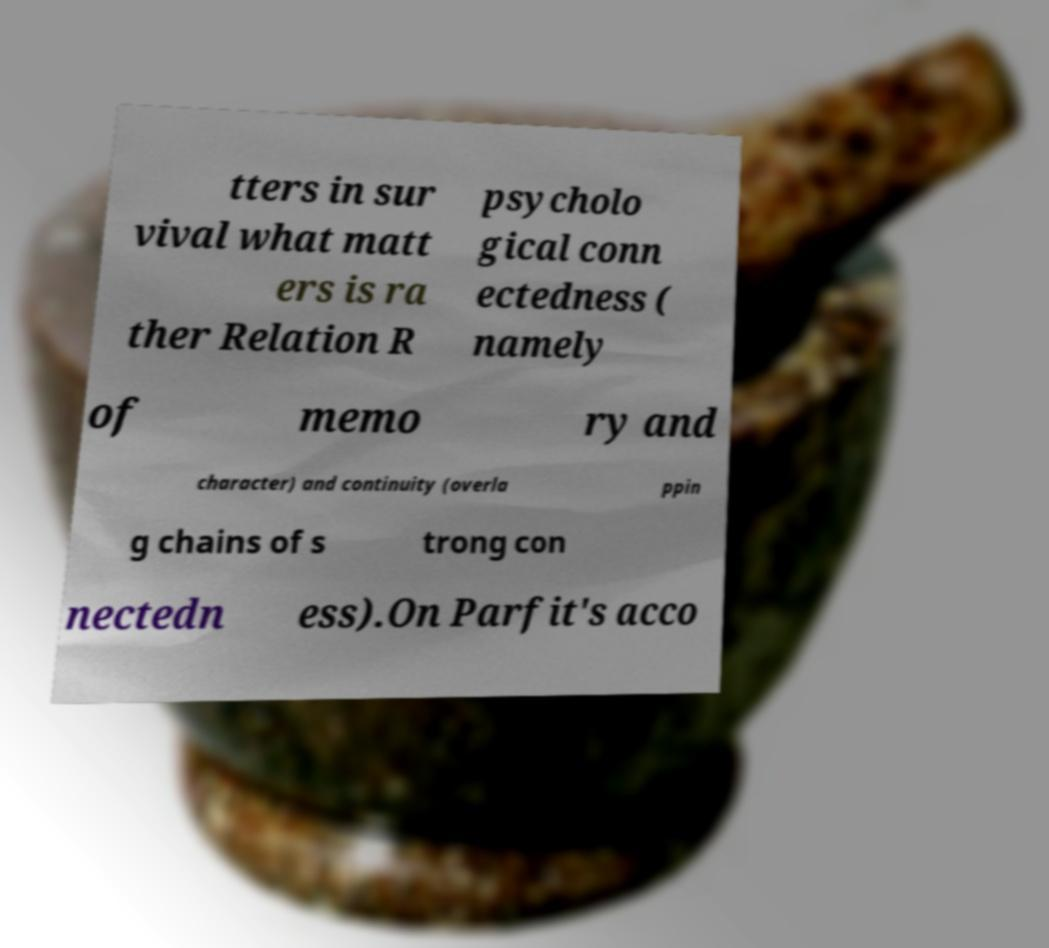Please identify and transcribe the text found in this image. tters in sur vival what matt ers is ra ther Relation R psycholo gical conn ectedness ( namely of memo ry and character) and continuity (overla ppin g chains of s trong con nectedn ess).On Parfit's acco 